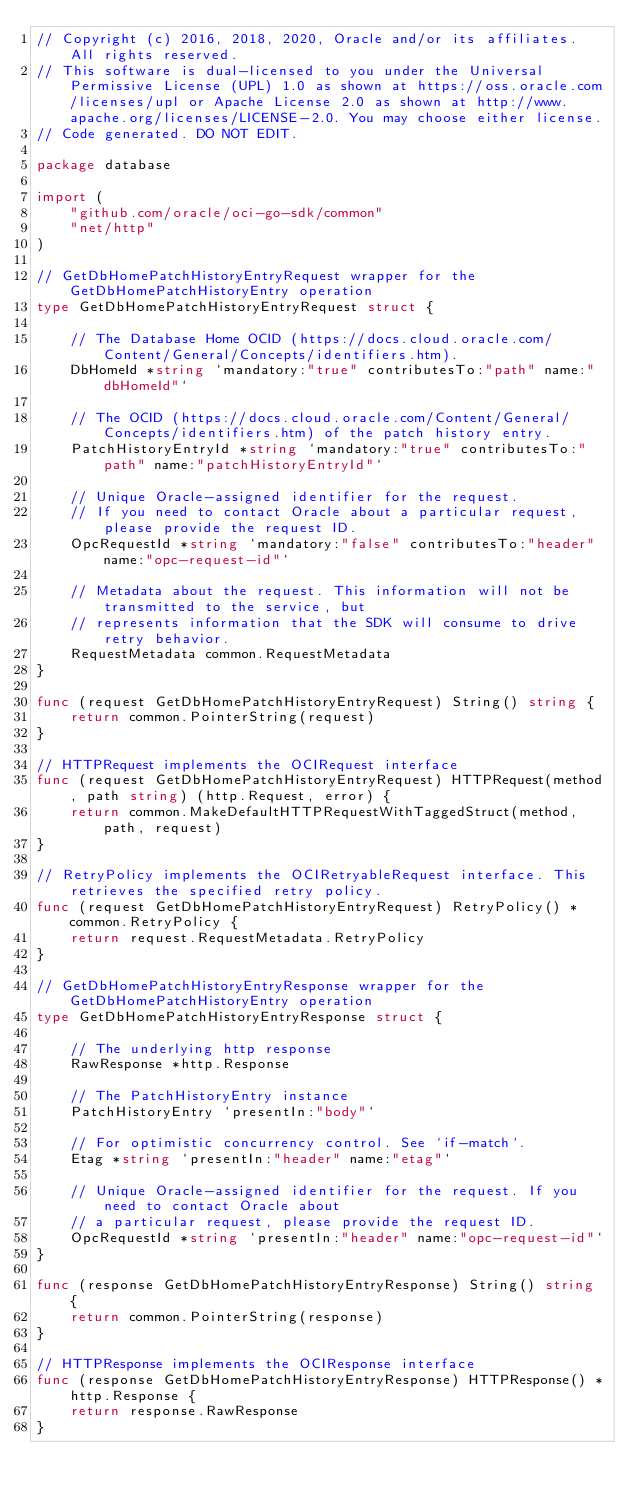Convert code to text. <code><loc_0><loc_0><loc_500><loc_500><_Go_>// Copyright (c) 2016, 2018, 2020, Oracle and/or its affiliates.  All rights reserved.
// This software is dual-licensed to you under the Universal Permissive License (UPL) 1.0 as shown at https://oss.oracle.com/licenses/upl or Apache License 2.0 as shown at http://www.apache.org/licenses/LICENSE-2.0. You may choose either license.
// Code generated. DO NOT EDIT.

package database

import (
	"github.com/oracle/oci-go-sdk/common"
	"net/http"
)

// GetDbHomePatchHistoryEntryRequest wrapper for the GetDbHomePatchHistoryEntry operation
type GetDbHomePatchHistoryEntryRequest struct {

	// The Database Home OCID (https://docs.cloud.oracle.com/Content/General/Concepts/identifiers.htm).
	DbHomeId *string `mandatory:"true" contributesTo:"path" name:"dbHomeId"`

	// The OCID (https://docs.cloud.oracle.com/Content/General/Concepts/identifiers.htm) of the patch history entry.
	PatchHistoryEntryId *string `mandatory:"true" contributesTo:"path" name:"patchHistoryEntryId"`

	// Unique Oracle-assigned identifier for the request.
	// If you need to contact Oracle about a particular request, please provide the request ID.
	OpcRequestId *string `mandatory:"false" contributesTo:"header" name:"opc-request-id"`

	// Metadata about the request. This information will not be transmitted to the service, but
	// represents information that the SDK will consume to drive retry behavior.
	RequestMetadata common.RequestMetadata
}

func (request GetDbHomePatchHistoryEntryRequest) String() string {
	return common.PointerString(request)
}

// HTTPRequest implements the OCIRequest interface
func (request GetDbHomePatchHistoryEntryRequest) HTTPRequest(method, path string) (http.Request, error) {
	return common.MakeDefaultHTTPRequestWithTaggedStruct(method, path, request)
}

// RetryPolicy implements the OCIRetryableRequest interface. This retrieves the specified retry policy.
func (request GetDbHomePatchHistoryEntryRequest) RetryPolicy() *common.RetryPolicy {
	return request.RequestMetadata.RetryPolicy
}

// GetDbHomePatchHistoryEntryResponse wrapper for the GetDbHomePatchHistoryEntry operation
type GetDbHomePatchHistoryEntryResponse struct {

	// The underlying http response
	RawResponse *http.Response

	// The PatchHistoryEntry instance
	PatchHistoryEntry `presentIn:"body"`

	// For optimistic concurrency control. See `if-match`.
	Etag *string `presentIn:"header" name:"etag"`

	// Unique Oracle-assigned identifier for the request. If you need to contact Oracle about
	// a particular request, please provide the request ID.
	OpcRequestId *string `presentIn:"header" name:"opc-request-id"`
}

func (response GetDbHomePatchHistoryEntryResponse) String() string {
	return common.PointerString(response)
}

// HTTPResponse implements the OCIResponse interface
func (response GetDbHomePatchHistoryEntryResponse) HTTPResponse() *http.Response {
	return response.RawResponse
}
</code> 